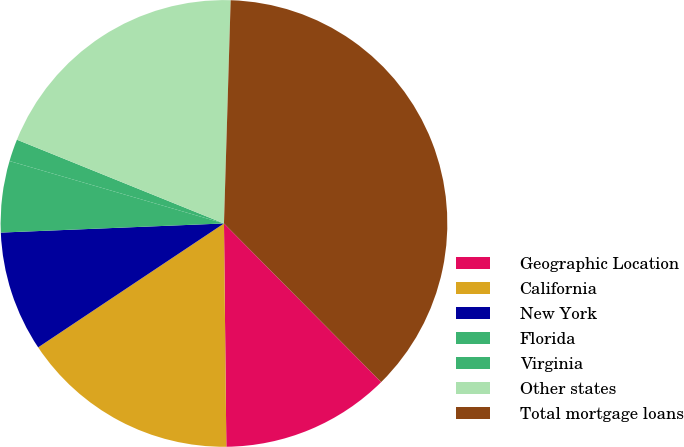Convert chart to OTSL. <chart><loc_0><loc_0><loc_500><loc_500><pie_chart><fcel>Geographic Location<fcel>California<fcel>New York<fcel>Florida<fcel>Virginia<fcel>Other states<fcel>Total mortgage loans<nl><fcel>12.26%<fcel>15.81%<fcel>8.71%<fcel>5.16%<fcel>1.61%<fcel>19.36%<fcel>37.1%<nl></chart> 